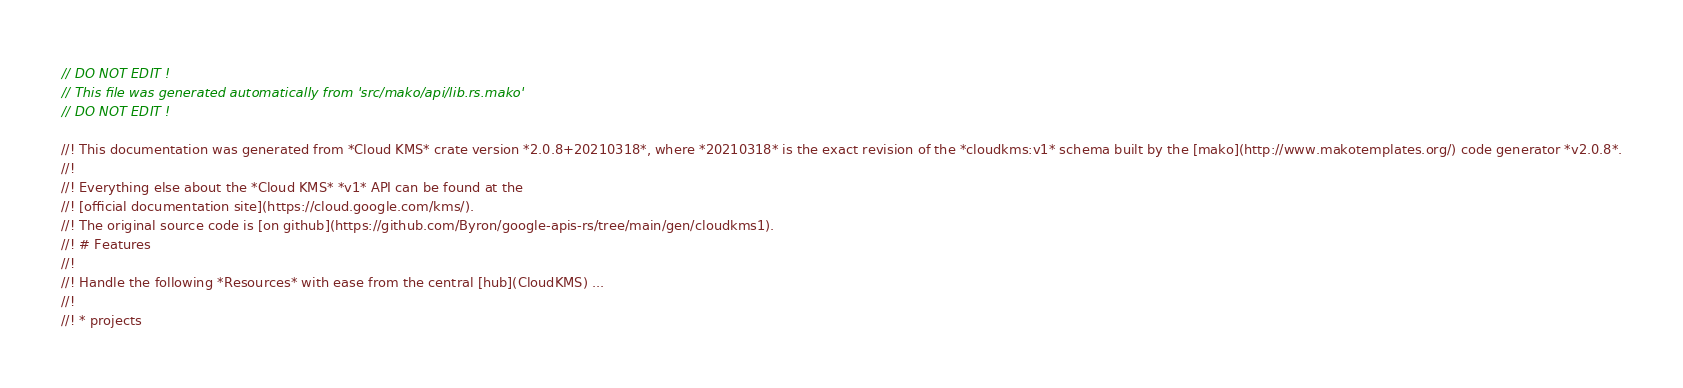Convert code to text. <code><loc_0><loc_0><loc_500><loc_500><_Rust_>// DO NOT EDIT !
// This file was generated automatically from 'src/mako/api/lib.rs.mako'
// DO NOT EDIT !

//! This documentation was generated from *Cloud KMS* crate version *2.0.8+20210318*, where *20210318* is the exact revision of the *cloudkms:v1* schema built by the [mako](http://www.makotemplates.org/) code generator *v2.0.8*.
//! 
//! Everything else about the *Cloud KMS* *v1* API can be found at the
//! [official documentation site](https://cloud.google.com/kms/).
//! The original source code is [on github](https://github.com/Byron/google-apis-rs/tree/main/gen/cloudkms1).
//! # Features
//! 
//! Handle the following *Resources* with ease from the central [hub](CloudKMS) ... 
//! 
//! * projects</code> 